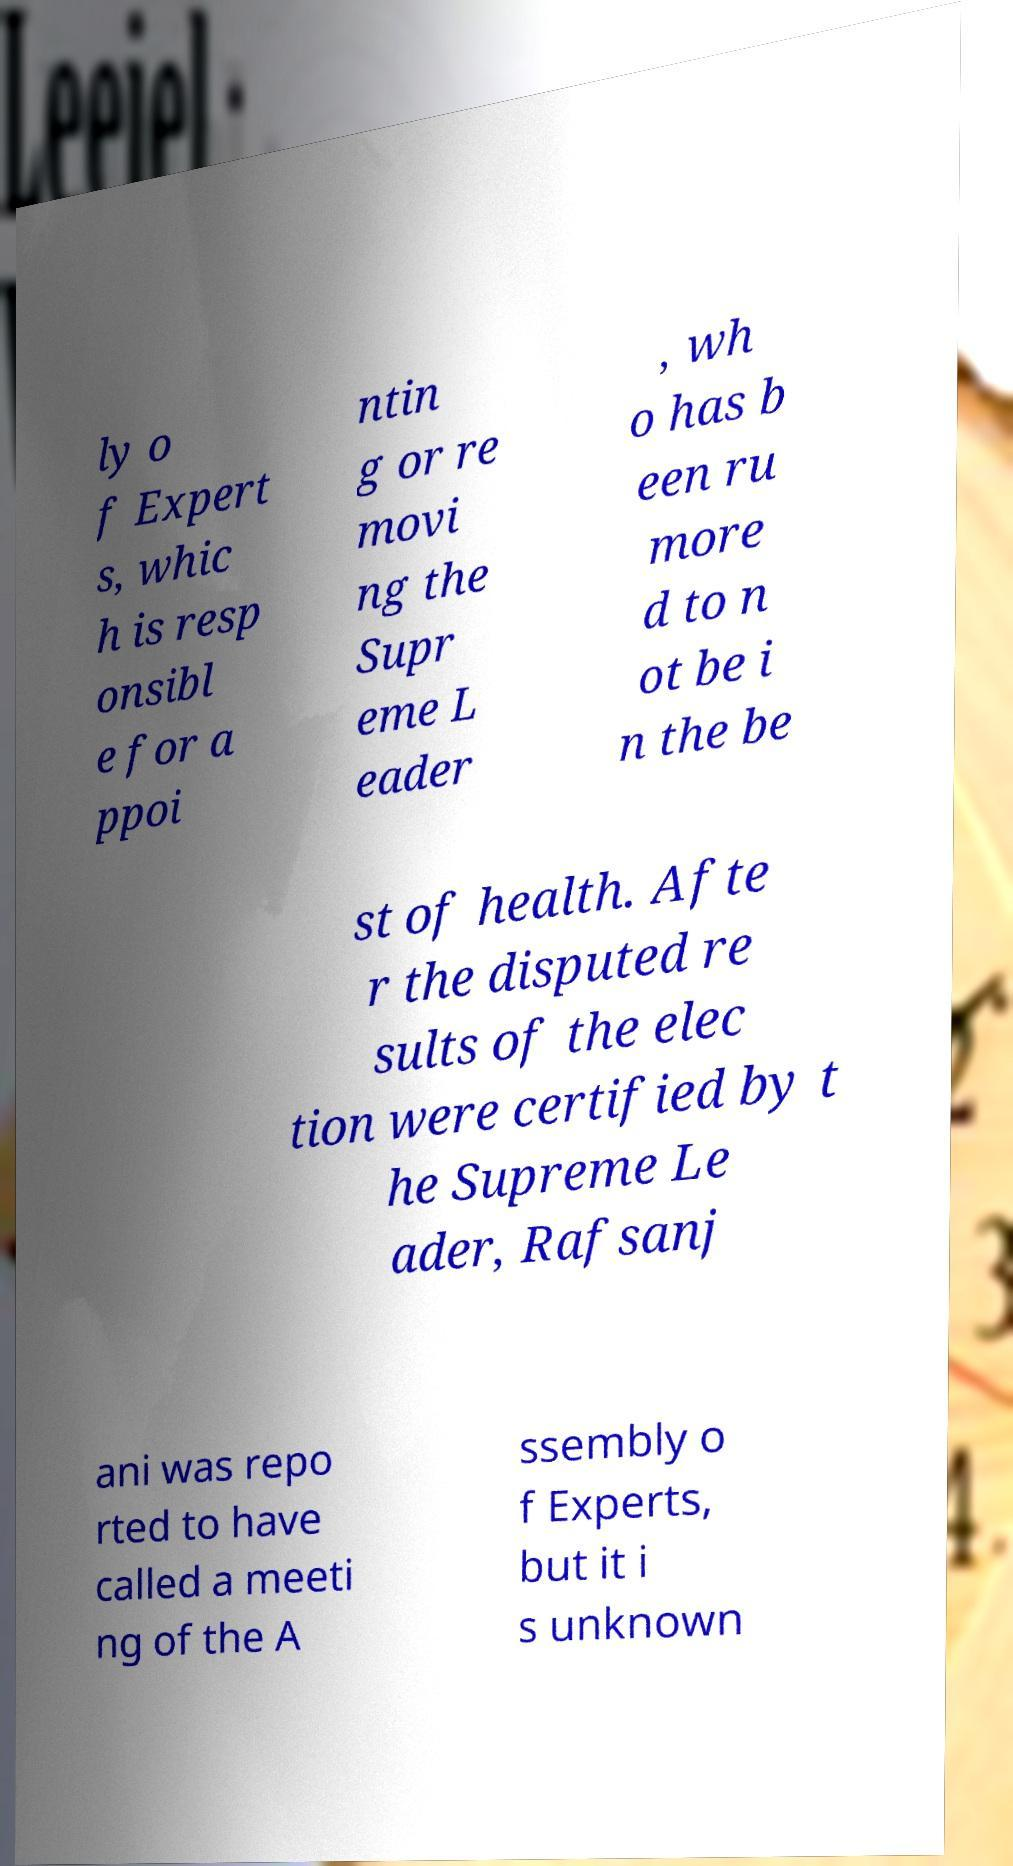Could you assist in decoding the text presented in this image and type it out clearly? ly o f Expert s, whic h is resp onsibl e for a ppoi ntin g or re movi ng the Supr eme L eader , wh o has b een ru more d to n ot be i n the be st of health. Afte r the disputed re sults of the elec tion were certified by t he Supreme Le ader, Rafsanj ani was repo rted to have called a meeti ng of the A ssembly o f Experts, but it i s unknown 